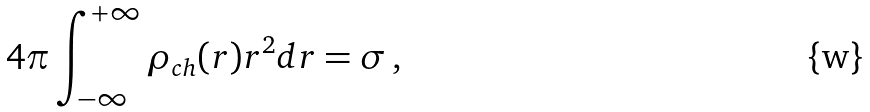<formula> <loc_0><loc_0><loc_500><loc_500>4 \pi \int _ { - \infty } ^ { + \infty } \rho _ { c h } ( r ) r ^ { 2 } d r = \sigma \, ,</formula> 